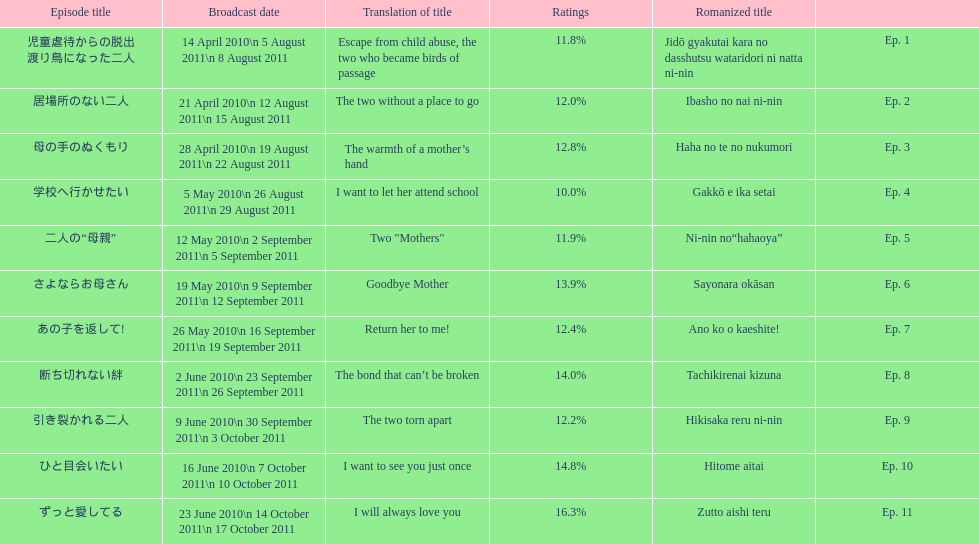Parse the full table. {'header': ['Episode title', 'Broadcast date', 'Translation of title', 'Ratings', 'Romanized title', ''], 'rows': [['児童虐待からの脱出 渡り鳥になった二人', '14 April 2010\\n 5 August 2011\\n 8 August 2011', 'Escape from child abuse, the two who became birds of passage', '11.8%', 'Jidō gyakutai kara no dasshutsu wataridori ni natta ni-nin', 'Ep. 1'], ['居場所のない二人', '21 April 2010\\n 12 August 2011\\n 15 August 2011', 'The two without a place to go', '12.0%', 'Ibasho no nai ni-nin', 'Ep. 2'], ['母の手のぬくもり', '28 April 2010\\n 19 August 2011\\n 22 August 2011', 'The warmth of a mother’s hand', '12.8%', 'Haha no te no nukumori', 'Ep. 3'], ['学校へ行かせたい', '5 May 2010\\n 26 August 2011\\n 29 August 2011', 'I want to let her attend school', '10.0%', 'Gakkō e ika setai', 'Ep. 4'], ['二人の“母親”', '12 May 2010\\n 2 September 2011\\n 5 September 2011', 'Two "Mothers"', '11.9%', 'Ni-nin no“hahaoya”', 'Ep. 5'], ['さよならお母さん', '19 May 2010\\n 9 September 2011\\n 12 September 2011', 'Goodbye Mother', '13.9%', 'Sayonara okāsan', 'Ep. 6'], ['あの子を返して!', '26 May 2010\\n 16 September 2011\\n 19 September 2011', 'Return her to me!', '12.4%', 'Ano ko o kaeshite!', 'Ep. 7'], ['断ち切れない絆', '2 June 2010\\n 23 September 2011\\n 26 September 2011', 'The bond that can’t be broken', '14.0%', 'Tachikirenai kizuna', 'Ep. 8'], ['引き裂かれる二人', '9 June 2010\\n 30 September 2011\\n 3 October 2011', 'The two torn apart', '12.2%', 'Hikisaka reru ni-nin', 'Ep. 9'], ['ひと目会いたい', '16 June 2010\\n 7 October 2011\\n 10 October 2011', 'I want to see you just once', '14.8%', 'Hitome aitai', 'Ep. 10'], ['ずっと愛してる', '23 June 2010\\n 14 October 2011\\n 17 October 2011', 'I will always love you', '16.3%', 'Zutto aishi teru', 'Ep. 11']]} How many episodes had a consecutive rating over 11%? 7. 